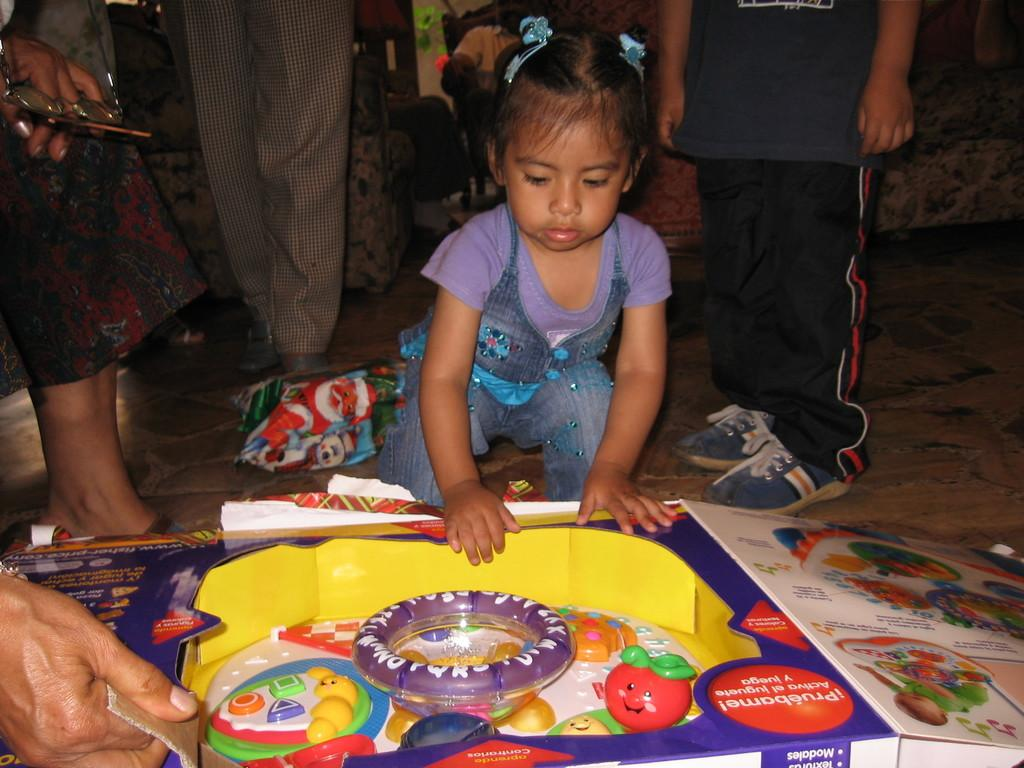Who can be seen in the image? There are people in the image. Can you describe the girl in the image? There is a girl in the middle of the image. What is in front of the girl? There is a box in front of the girl. What can be found near the box? There are toys near the box. What is visible in the background of the image? There is a sofa in the background of the image. What type of fiction is the girl reading in the image? There is no book or any form of fiction present in the image. What is the girl's favorite flavor of cream in the image? There is no mention of cream or any food item in the image. 